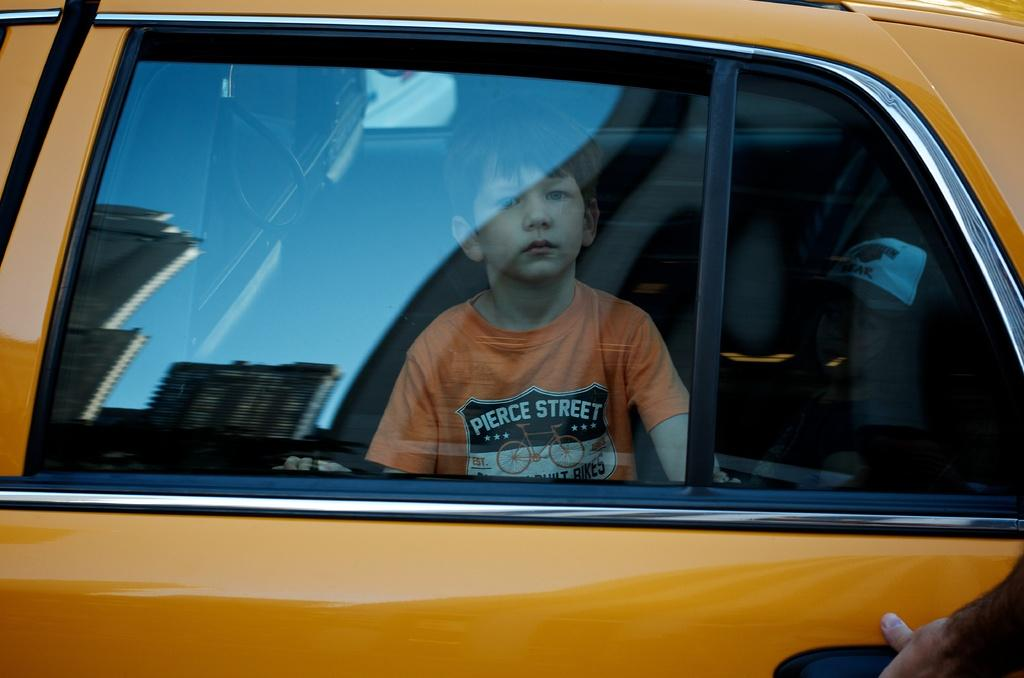<image>
Provide a brief description of the given image. a boy with a shirt that says Pierce street sits in a taxi 